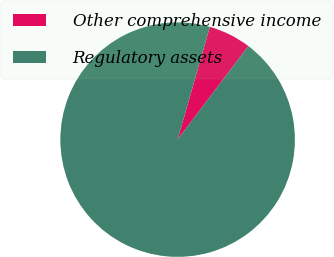Convert chart. <chart><loc_0><loc_0><loc_500><loc_500><pie_chart><fcel>Other comprehensive income<fcel>Regulatory assets<nl><fcel>5.88%<fcel>94.12%<nl></chart> 